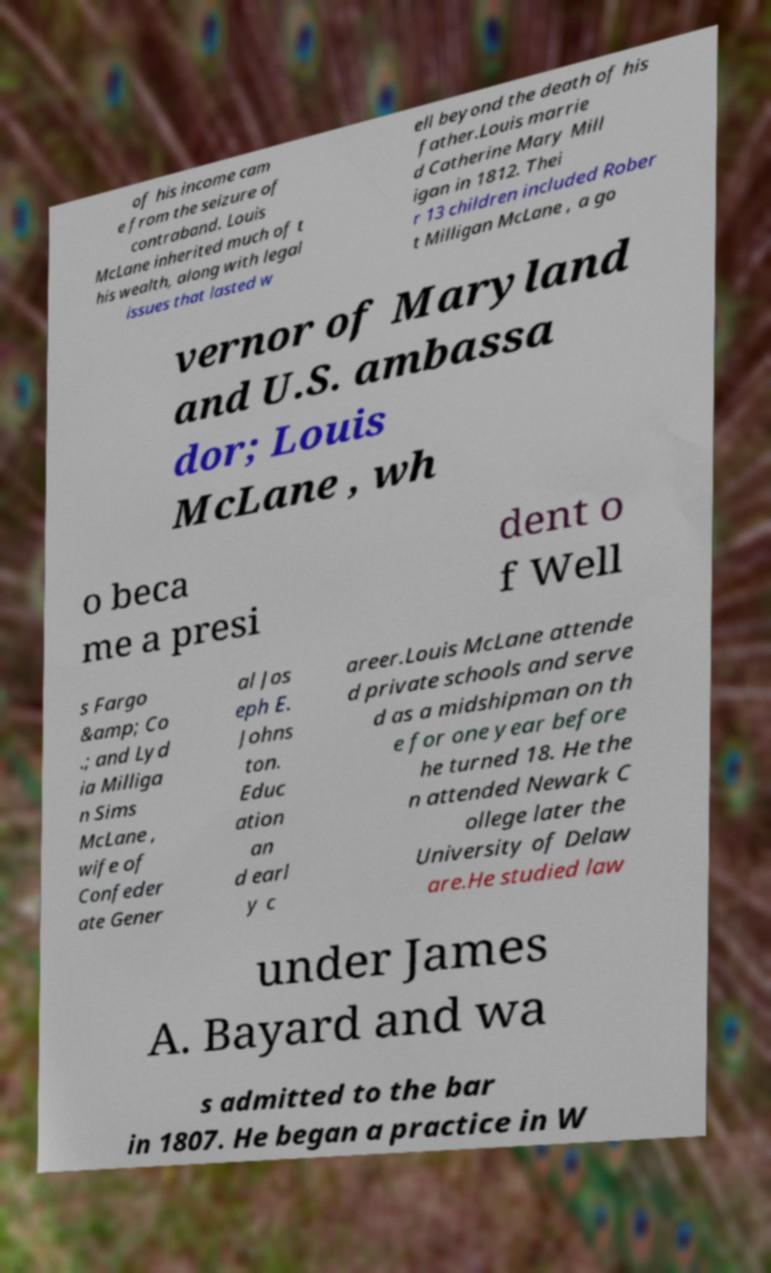Can you read and provide the text displayed in the image?This photo seems to have some interesting text. Can you extract and type it out for me? of his income cam e from the seizure of contraband. Louis McLane inherited much of t his wealth, along with legal issues that lasted w ell beyond the death of his father.Louis marrie d Catherine Mary Mill igan in 1812. Thei r 13 children included Rober t Milligan McLane , a go vernor of Maryland and U.S. ambassa dor; Louis McLane , wh o beca me a presi dent o f Well s Fargo &amp; Co .; and Lyd ia Milliga n Sims McLane , wife of Confeder ate Gener al Jos eph E. Johns ton. Educ ation an d earl y c areer.Louis McLane attende d private schools and serve d as a midshipman on th e for one year before he turned 18. He the n attended Newark C ollege later the University of Delaw are.He studied law under James A. Bayard and wa s admitted to the bar in 1807. He began a practice in W 